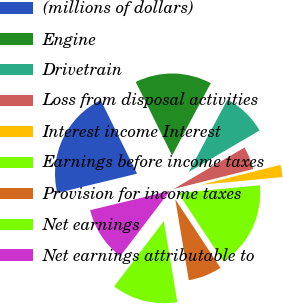Convert chart. <chart><loc_0><loc_0><loc_500><loc_500><pie_chart><fcel>(millions of dollars)<fcel>Engine<fcel>Drivetrain<fcel>Loss from disposal activities<fcel>Interest income Interest<fcel>Earnings before income taxes<fcel>Provision for income taxes<fcel>Net earnings<fcel>Net earnings attributable to<nl><fcel>21.47%<fcel>15.11%<fcel>8.76%<fcel>4.52%<fcel>2.4%<fcel>17.23%<fcel>6.64%<fcel>12.99%<fcel>10.88%<nl></chart> 